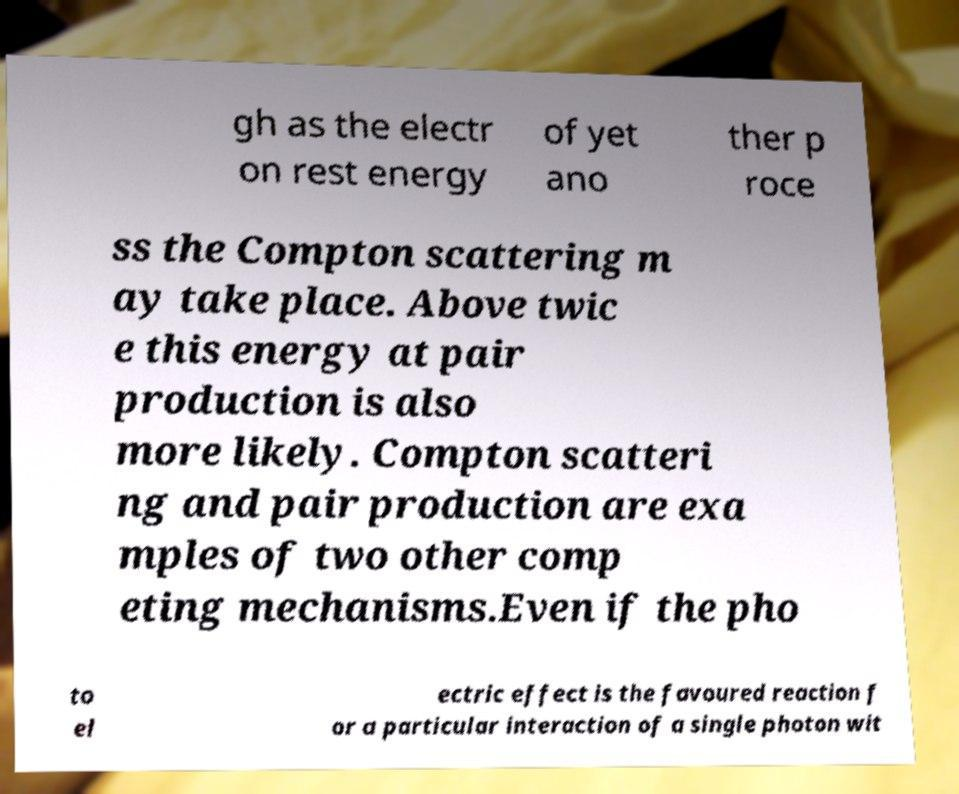Could you assist in decoding the text presented in this image and type it out clearly? gh as the electr on rest energy of yet ano ther p roce ss the Compton scattering m ay take place. Above twic e this energy at pair production is also more likely. Compton scatteri ng and pair production are exa mples of two other comp eting mechanisms.Even if the pho to el ectric effect is the favoured reaction f or a particular interaction of a single photon wit 